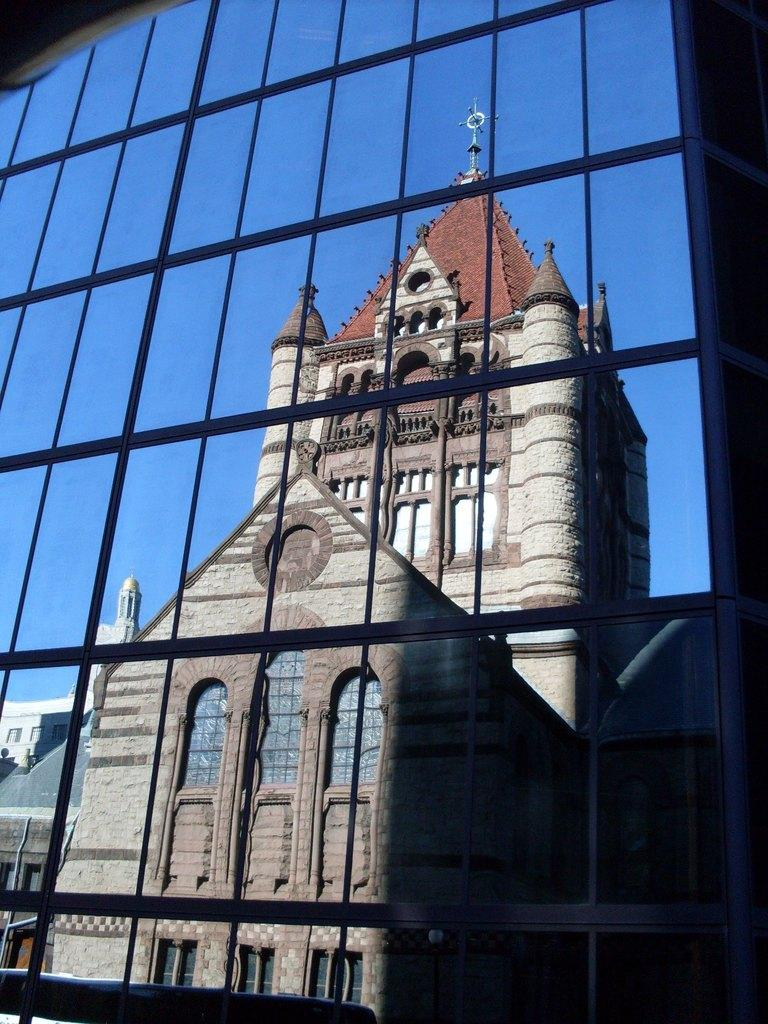What type of structures can be seen in the image? There are buildings in the image. What part of the natural environment is visible in the image? The sky is visible in the image. How many icicles are hanging from the buildings in the image? There are no icicles visible in the image. Can you describe the way the frog is hopping in the image? There is no frog present in the image. 